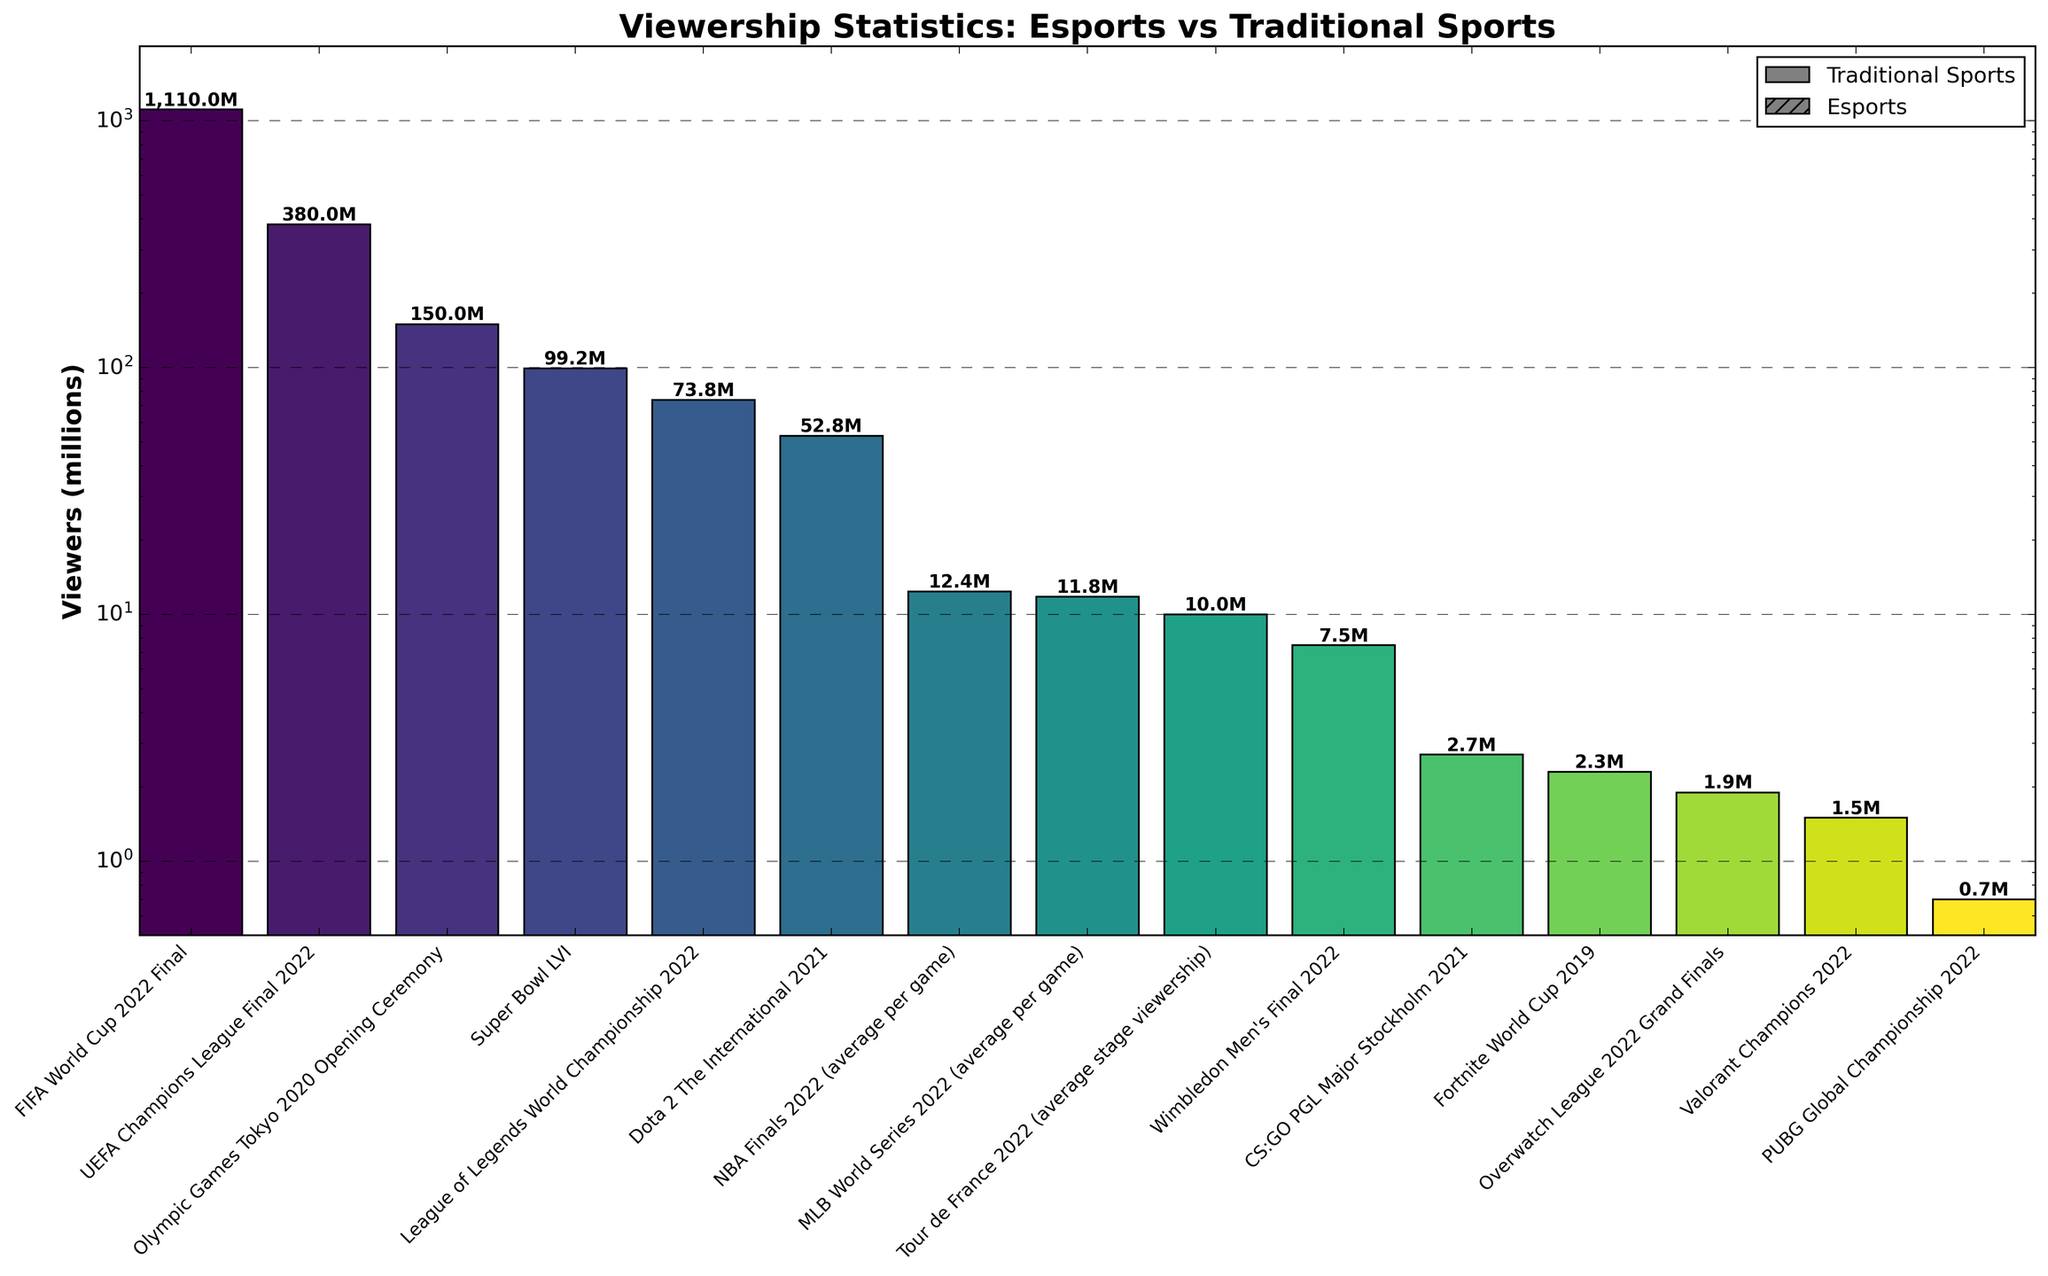What event had the highest viewership? The event with the highest bar represents the event with the highest viewership. This is the FIFA World Cup 2022 Final.
Answer: FIFA World Cup 2022 Final How does the viewership of the Super Bowl LVI compare to that of the League of Legends World Championship 2022? Compare the heights of the bars for these two events. The Super Bowl LVI has a higher viewership than the League of Legends World Championship 2022.
Answer: Super Bowl LVI What is the ratio of the viewership of the FIFA World Cup 2022 Final to the NBA Finals 2022? The viewership of the FIFA World Cup 2022 Final is 1110 million, and for the NBA Finals 2022, it’s 12.4 million. The ratio is 1110 / 12.4.
Answer: 89.5 Which esports event had the lowest viewership? Among the bars marked with hatches (representing esports), the lowest one is for the PUBG Global Championship 2022.
Answer: PUBG Global Championship 2022 What is the difference in viewership between the Olympic Games Tokyo 2020 Opening Ceremony and the Wimbledon Men's Final 2022? Subtract the viewership of Wimbledon Men's Final 2022 (7.5 million) from the Olympic Games Tokyo 2020 Opening Ceremony (150 million). The difference is 150 - 7.5.
Answer: 142.5 million What is the combined viewership of Dota 2 The International 2021 and the UEFA Champions League Final 2022? Add the viewership of Dota 2 The International 2021 (52.8 million) and the UEFA Champions League Final 2022 (380 million). The sum is 52.8 + 380.
Answer: 432.8 million Which event has a viewership closest to 10 million? Looking at the bars’ heights, the closest event to 10 million viewers is the Tour de France 2022 with an average stage viewership of 10 million.
Answer: Tour de France 2022 Are there more esports events or traditional sports events listed in the chart? Count the number of esports events and traditional sports events. There are 7 esports events (marked with hatches) and 8 traditional sports events, so there are more traditional sports events.
Answer: Traditional sports events Between the Overwatch League 2022 Grand Finals and the Fortnite World Cup 2019, which had higher viewership, and by how much? Compare the heights of these two bars. Overwatch League 2022 Grand Finals had 1.9 million viewers, and Fortnite World Cup 2019 had 2.3 million viewers. The difference is 2.3 - 1.9.
Answer: Fortnite World Cup 2019, 0.4 million What is the median viewership of all events listed in the chart? To find the median, list all the viewership values in ascending order, and find the middle value. The sorted values are [0.7, 1.5, 1.9, 2.3, 2.7, 7.5, 10, 11.8, 12.4, 52.8, 73.8, 99.2, 150, 380, 1110]. The median is the 8th value.
Answer: 11.8 million 